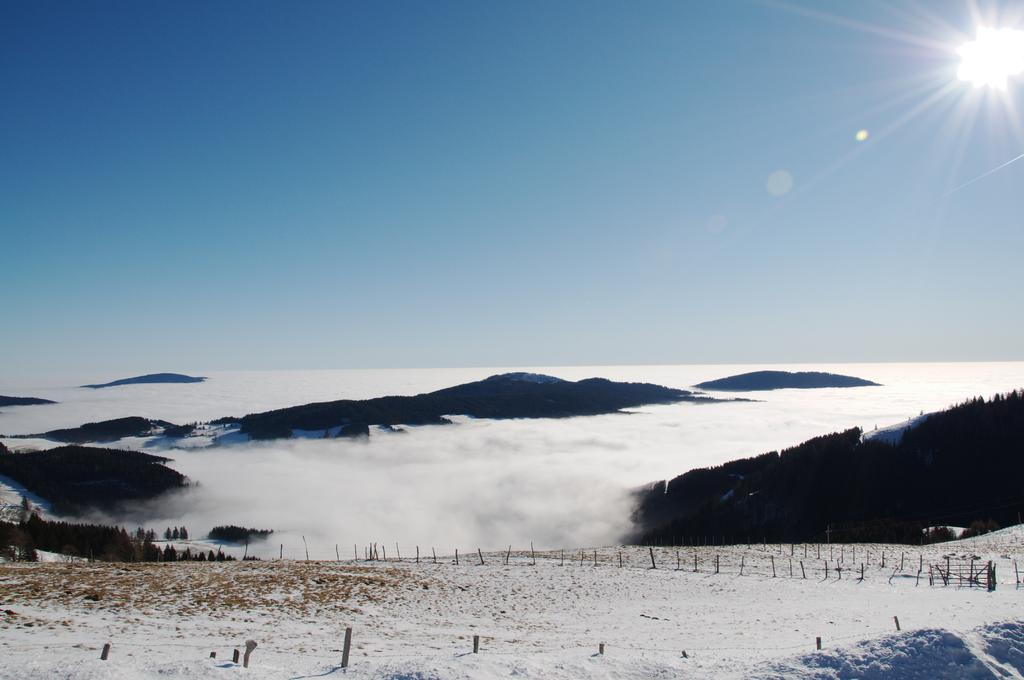What type of barrier can be seen in the image? There is a fence in the image. What type of vegetation is present in the image? There are trees in the image. What weather condition is depicted in the image? There is snow in the image. What natural light source is visible in the image? Sunlight is visible in the image. What part of the environment is visible in the image? The sky is visible in the image. Based on the presence of sunlight, can we determine the time of day the image was taken? The image was likely taken during the day. What note is being played on the wheel in the image? There is no wheel or note being played in the image; it features a fence, trees, snow, sunlight, and the sky. What time of the afternoon was the image taken? The time of the afternoon cannot be determined from the image, as it only provides information about the presence of sunlight and snow. 